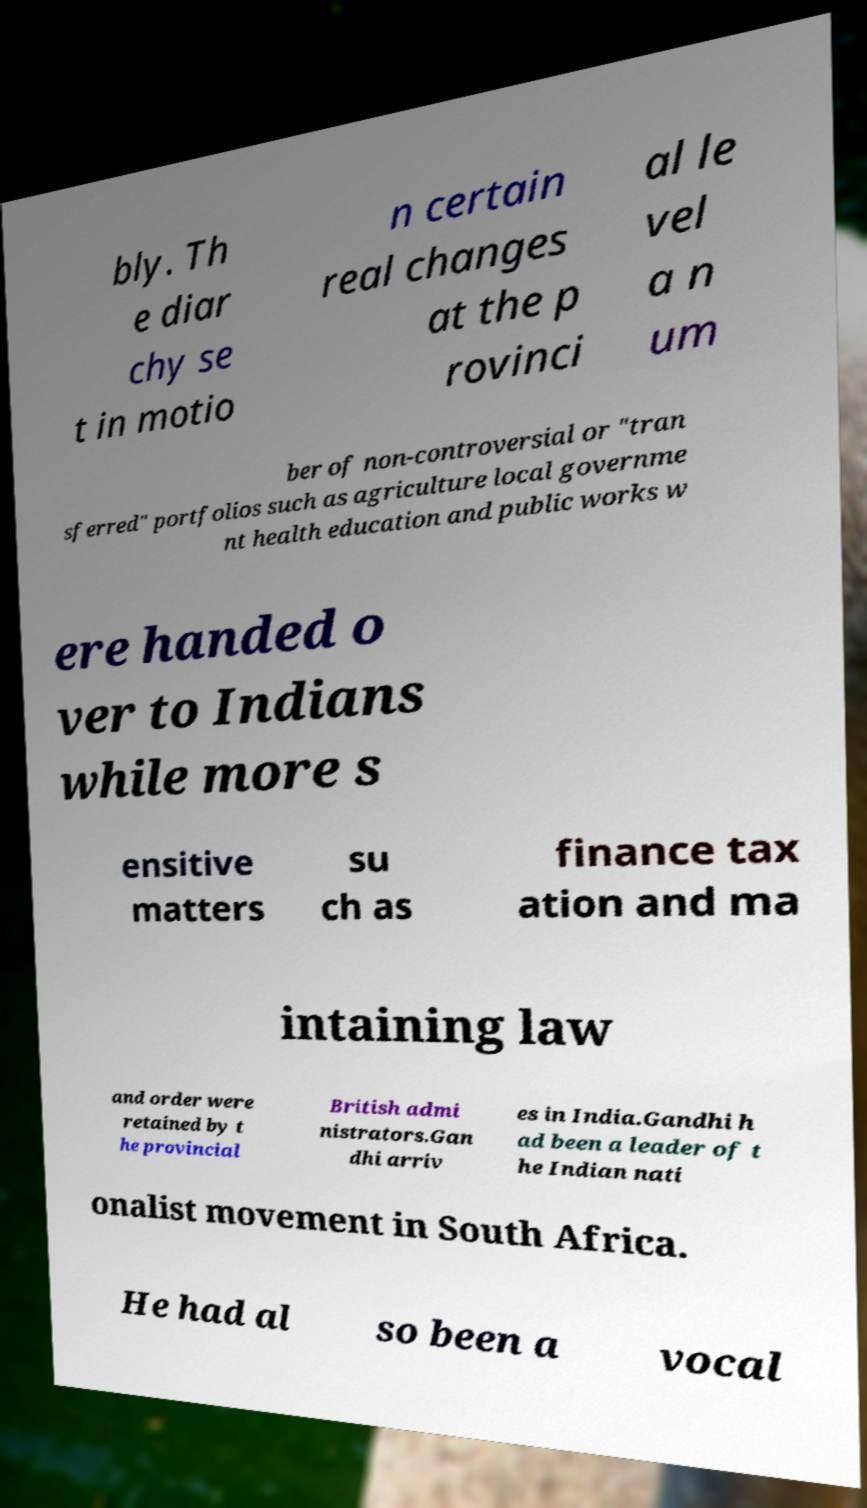For documentation purposes, I need the text within this image transcribed. Could you provide that? bly. Th e diar chy se t in motio n certain real changes at the p rovinci al le vel a n um ber of non-controversial or "tran sferred" portfolios such as agriculture local governme nt health education and public works w ere handed o ver to Indians while more s ensitive matters su ch as finance tax ation and ma intaining law and order were retained by t he provincial British admi nistrators.Gan dhi arriv es in India.Gandhi h ad been a leader of t he Indian nati onalist movement in South Africa. He had al so been a vocal 